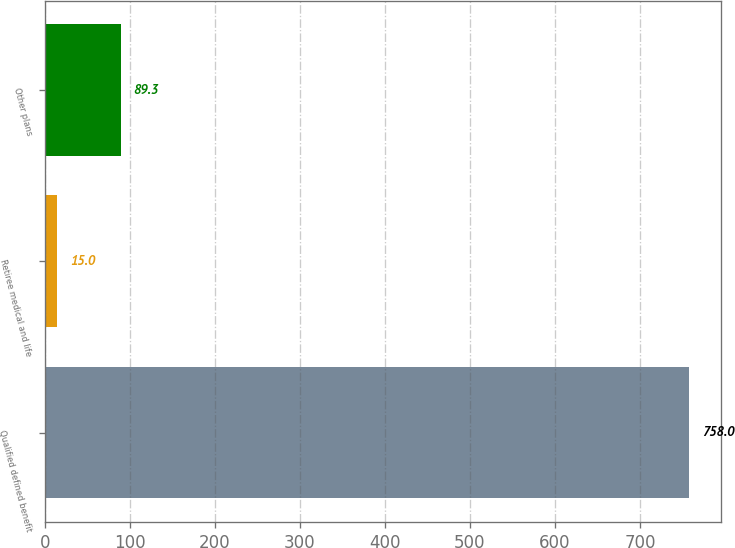Convert chart. <chart><loc_0><loc_0><loc_500><loc_500><bar_chart><fcel>Qualified defined benefit<fcel>Retiree medical and life<fcel>Other plans<nl><fcel>758<fcel>15<fcel>89.3<nl></chart> 